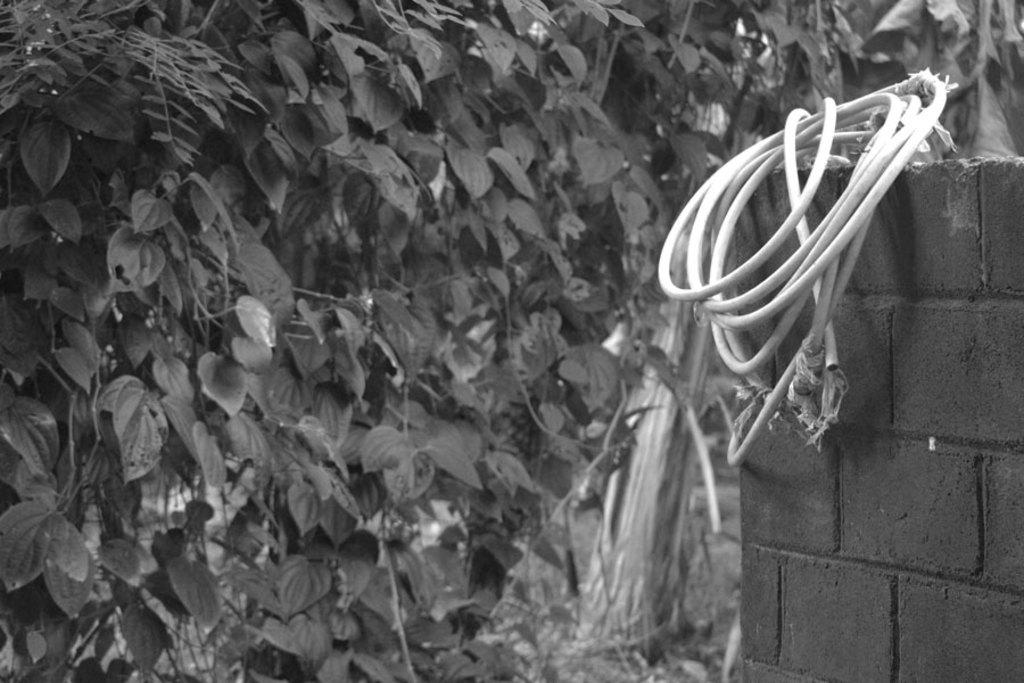What can be seen on the right side of the image? There is a wire on the right side of the image. Where is the wire located? The wire is on a brick wall. What is on the left side of the image? There are plants on the left side of the image. What is a characteristic of the plants in the image? Leaves are present in the image. What type of engine can be seen running in the image? There is no engine present in the image. What sheet is covering the plants in the image? There is no sheet covering the plants in the image; they are visible with their leaves. 